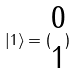Convert formula to latex. <formula><loc_0><loc_0><loc_500><loc_500>| 1 \rangle = ( \begin{matrix} 0 \\ 1 \end{matrix} )</formula> 